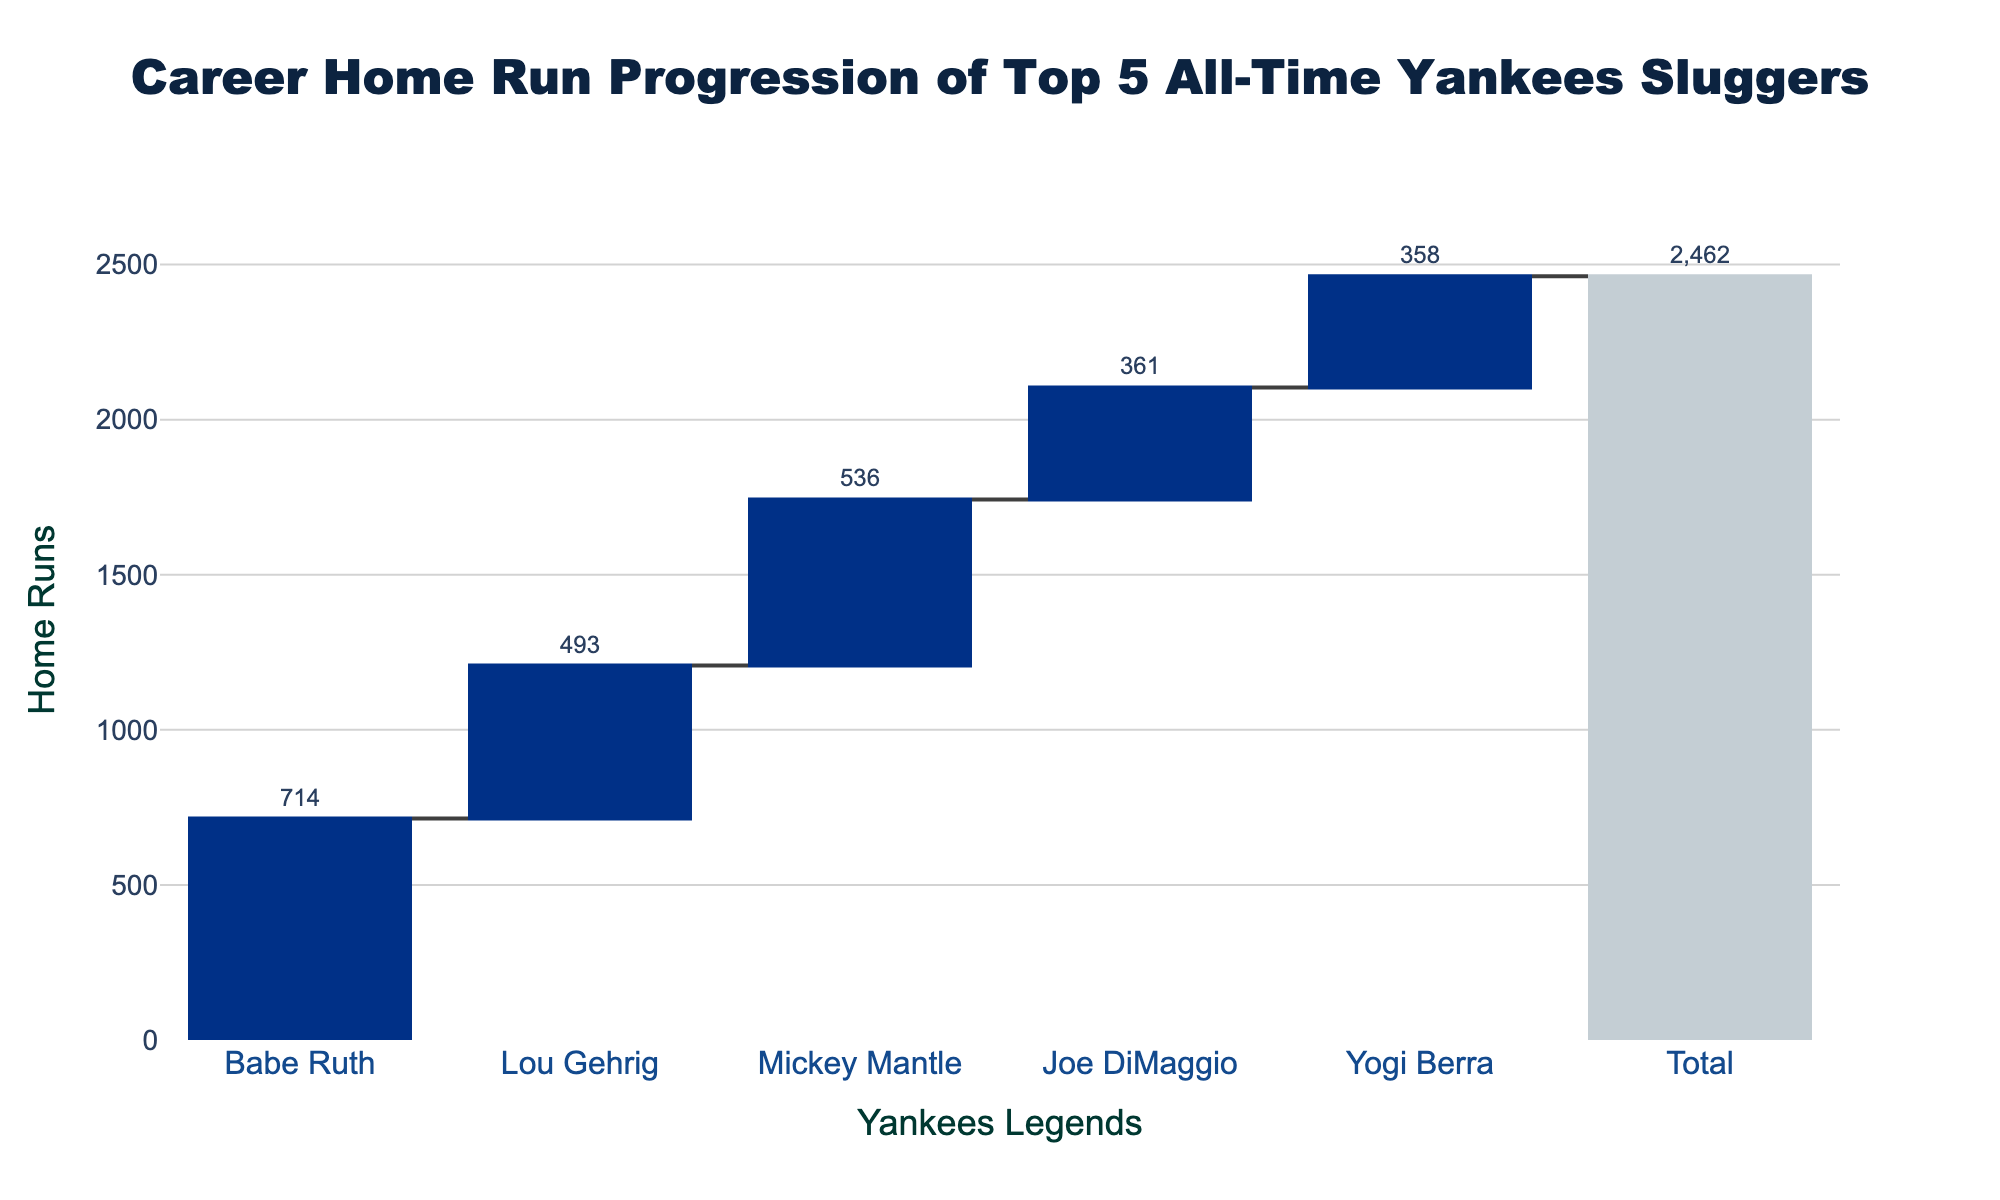what is the total number of home runs hit by the top 5 Yankees sluggers? The title of the chart is "Career Home Run Progression of Top 5 All-Time Yankees Sluggers". The "Total" bar at the end of the chart represents the sum of the home runs by the five players. To find the total, add the home runs of Babe Ruth (714), Lou Gehrig (493), Mickey Mantle (536), Joe DiMaggio (361), and Yogi Berra (358), resulting in 2462.
Answer: 2462 Which player has hit the most home runs among the top 5 Yankees? Observe the chart's bar heights and labels. The tallest bar is for Babe Ruth, labeled with a value of 714, which is the highest number among the players listed.
Answer: Babe Ruth How many more home runs did Mickey Mantle hit compared to Lou Gehrig? Look at the values next to Mickey Mantle and Lou Gehrig bars. Mickey Mantle has 536 home runs, while Lou Gehrig has 493. Subtract Gehrig's value from Mantle's: 536 - 493.
Answer: 43 Among the top 5 Yankees sluggers, who has the least number of home runs? Check the smallest bar on the chart. It corresponds to Yogi Berra, labeled with 358 home runs, which is the lowest number among the players listed.
Answer: Yogi Berra How many home runs were hit by Joe DiMaggio and Yogi Berra combined? Add the home runs for Joe DiMaggio (361) and Yogi Berra (358): 361 + 358.
Answer: 719 Compare Lou Gehrig and Joe DiMaggio. Who hit more home runs and by what difference? Look at the respective bars for Lou Gehrig (493) and Joe DiMaggio (361). Lou Gehrig hit more home runs. Subtract DiMaggio's total from Gehrig's: 493 - 361.
Answer: Lou Gehrig, by 132 What is the average number of home runs hit by the top 5 Yankees sluggers? Sum the home runs by all five players: 714 + 493 + 536 + 361 + 358 = 2462. Divide this total by the number of players, 5.
Answer: 492.4 